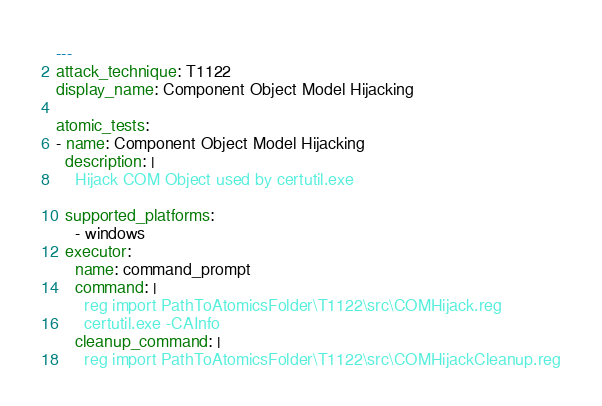Convert code to text. <code><loc_0><loc_0><loc_500><loc_500><_YAML_>---
attack_technique: T1122
display_name: Component Object Model Hijacking

atomic_tests:
- name: Component Object Model Hijacking
  description: |
    Hijack COM Object used by certutil.exe

  supported_platforms:
    - windows
  executor:
    name: command_prompt
    command: |
      reg import PathToAtomicsFolder\T1122\src\COMHijack.reg
      certutil.exe -CAInfo
    cleanup_command: |
      reg import PathToAtomicsFolder\T1122\src\COMHijackCleanup.reg
</code> 